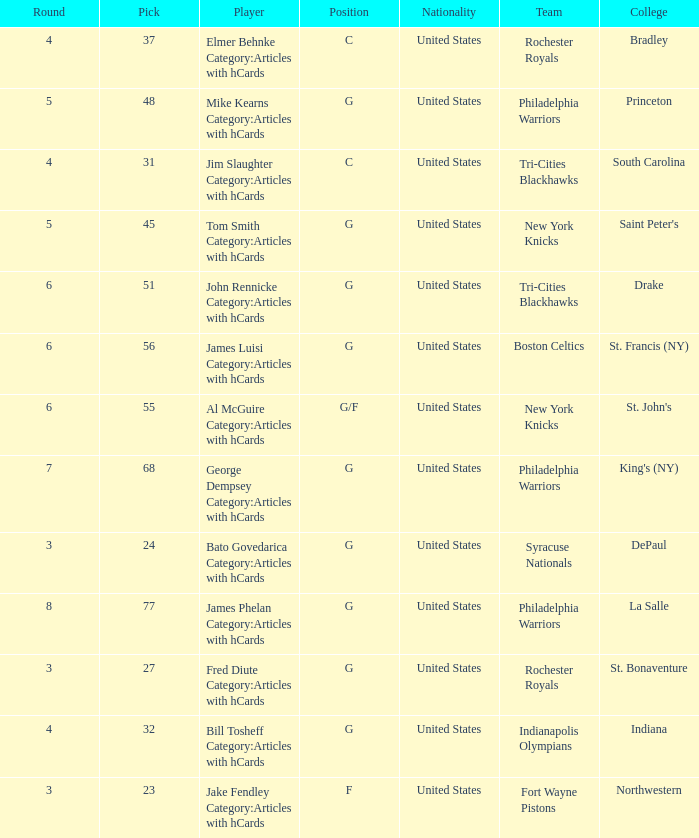What is the aggregate amount of choices for drake participants from the tri-cities blackhawks? 51.0. 